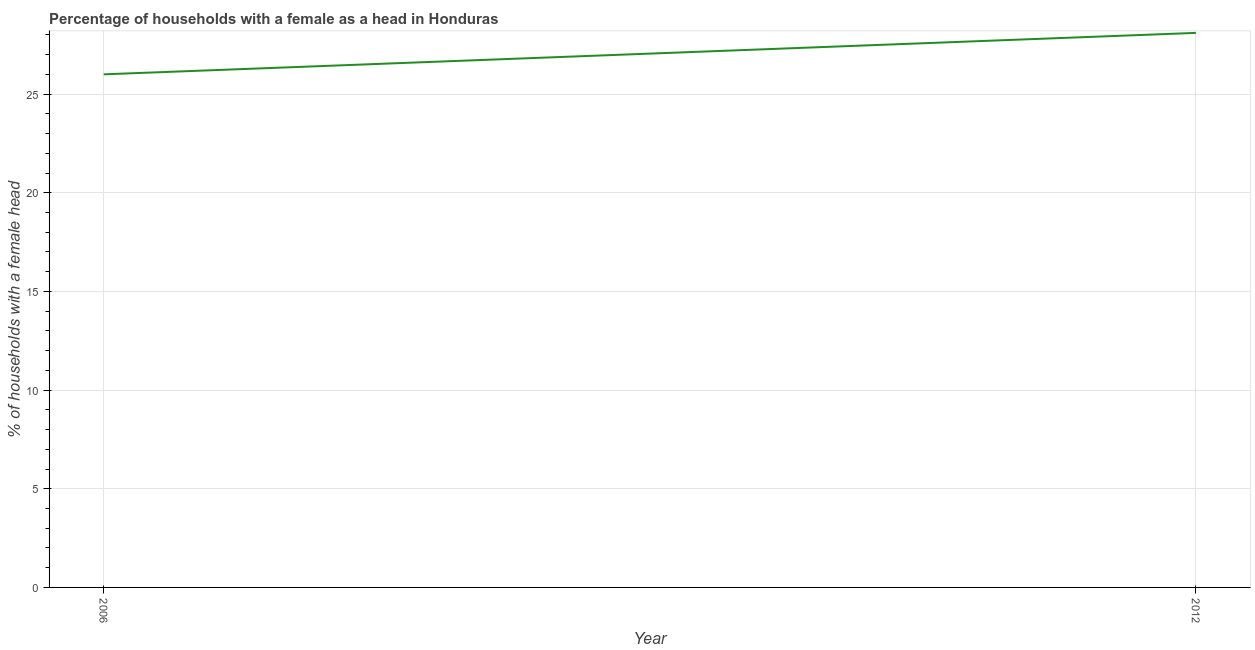What is the number of female supervised households in 2006?
Keep it short and to the point. 26. Across all years, what is the maximum number of female supervised households?
Keep it short and to the point. 28.1. In which year was the number of female supervised households maximum?
Provide a short and direct response. 2012. What is the sum of the number of female supervised households?
Keep it short and to the point. 54.1. What is the difference between the number of female supervised households in 2006 and 2012?
Your response must be concise. -2.1. What is the average number of female supervised households per year?
Provide a short and direct response. 27.05. What is the median number of female supervised households?
Keep it short and to the point. 27.05. What is the ratio of the number of female supervised households in 2006 to that in 2012?
Offer a terse response. 0.93. Is the number of female supervised households in 2006 less than that in 2012?
Provide a short and direct response. Yes. Does the number of female supervised households monotonically increase over the years?
Your answer should be compact. Yes. How many lines are there?
Offer a very short reply. 1. What is the difference between two consecutive major ticks on the Y-axis?
Offer a terse response. 5. What is the title of the graph?
Provide a short and direct response. Percentage of households with a female as a head in Honduras. What is the label or title of the Y-axis?
Offer a very short reply. % of households with a female head. What is the % of households with a female head in 2012?
Offer a very short reply. 28.1. What is the ratio of the % of households with a female head in 2006 to that in 2012?
Your answer should be very brief. 0.93. 